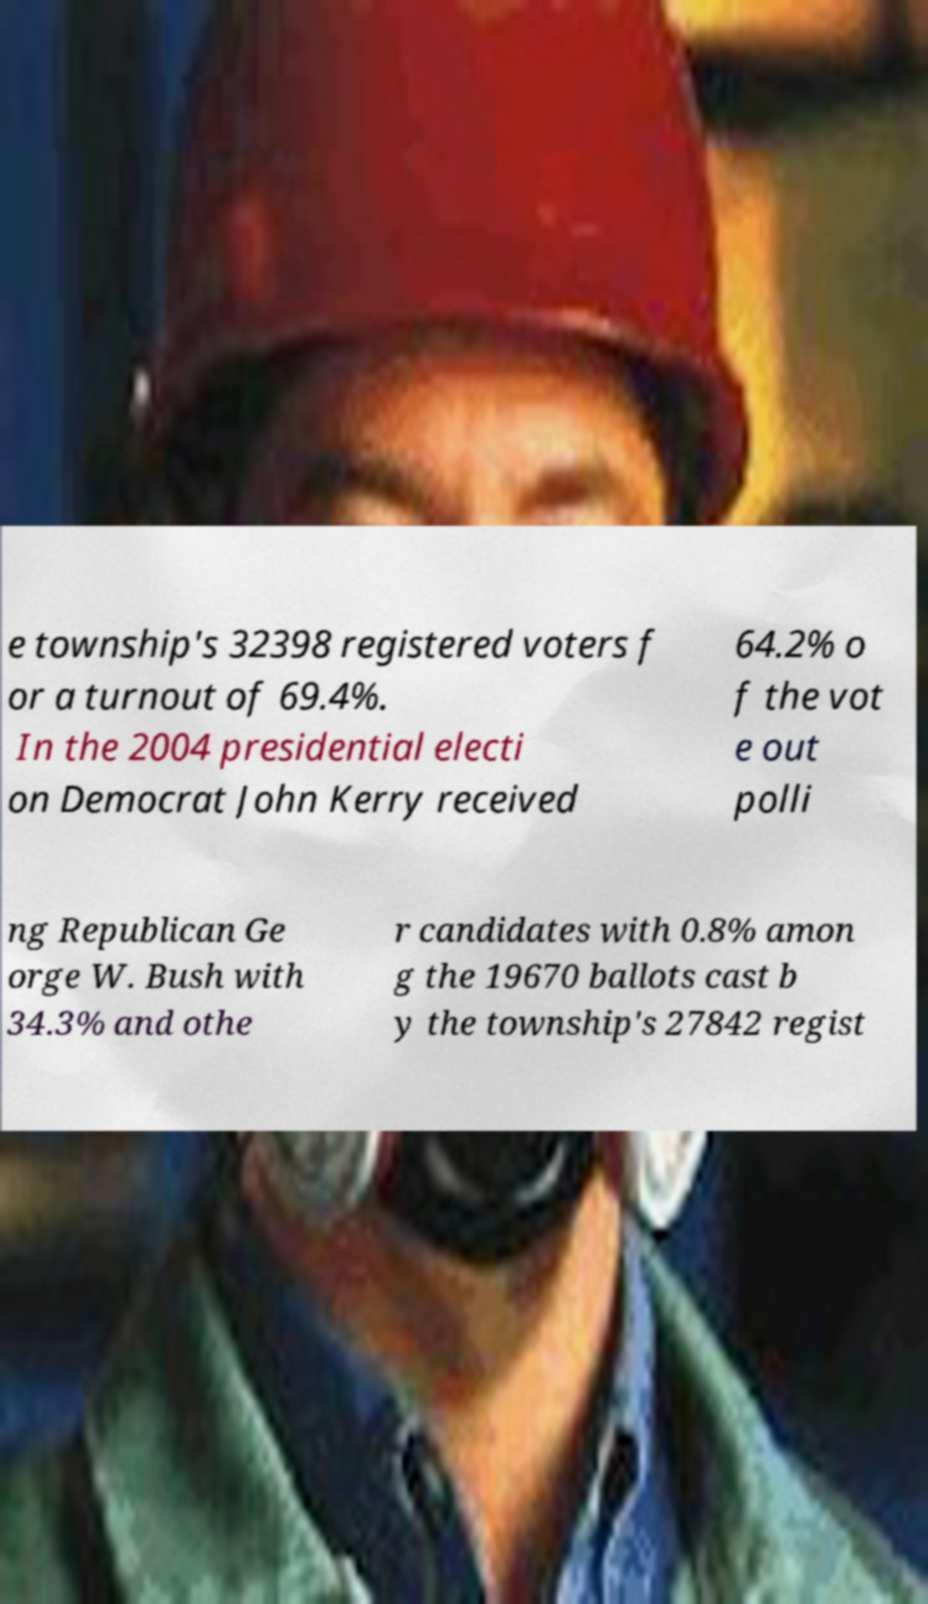Please read and relay the text visible in this image. What does it say? e township's 32398 registered voters f or a turnout of 69.4%. In the 2004 presidential electi on Democrat John Kerry received 64.2% o f the vot e out polli ng Republican Ge orge W. Bush with 34.3% and othe r candidates with 0.8% amon g the 19670 ballots cast b y the township's 27842 regist 